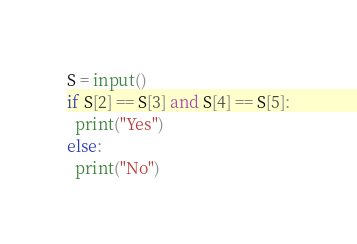<code> <loc_0><loc_0><loc_500><loc_500><_Python_>S = input()
if S[2] == S[3] and S[4] == S[5]:
  print("Yes")
else:
  print("No")</code> 